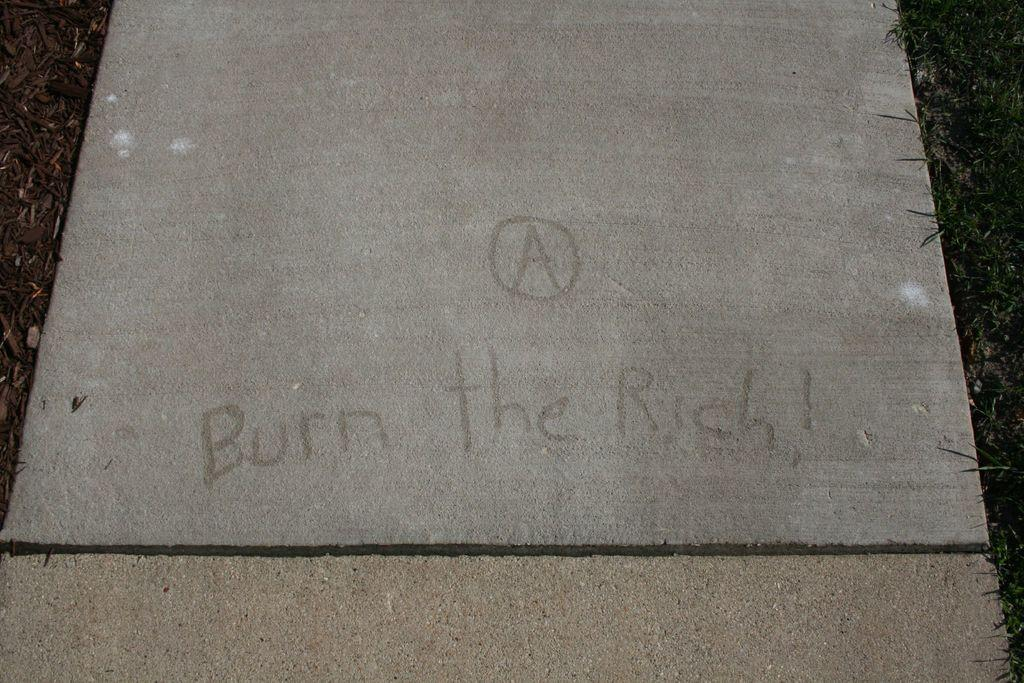What type of material is the tile in the image made of? The tile in the image is made of stone. What message is written on the stone tile? The stone tile has the words "Burn the Rich" written on it. Where is the stone tile located in the image? The stone tile is placed on the ground. What is covering the ground in the image? The ground is covered with grass. How many heads of lettuce can be seen in the image? There are no heads of lettuce present in the image. 